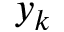<formula> <loc_0><loc_0><loc_500><loc_500>y _ { k }</formula> 